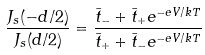Convert formula to latex. <formula><loc_0><loc_0><loc_500><loc_500>\frac { J _ { s } ( - d / 2 ) } { J _ { s } ( d / 2 ) } = \frac { \bar { t } _ { - } + \bar { t } _ { + } e ^ { - e V / k T } } { \bar { t } _ { + } + \bar { t } _ { - } e ^ { - e V / k T } }</formula> 